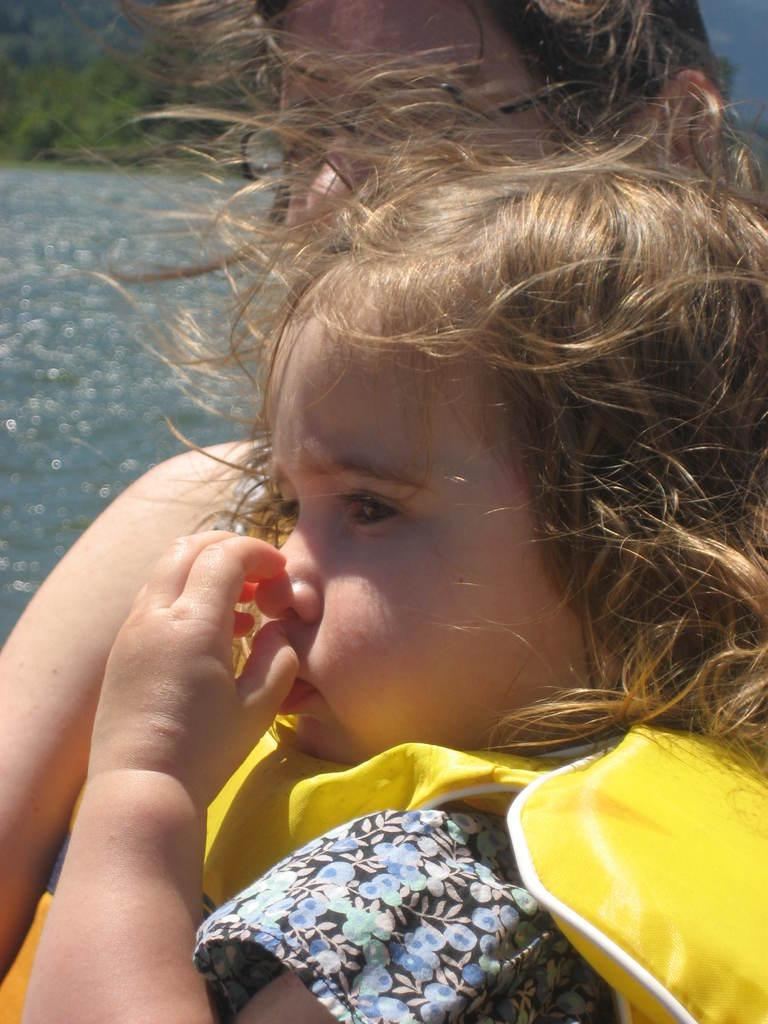Who is present in the image? A: There is a lady and a girl in the image. What is the girl wearing? The girl is wearing a life jacket. What can be seen in the background of the image? There are trees visible in the image. What is the condition of the background in the image? The background of the image is blurred. What year is depicted in the image? The provided facts do not mention any specific year, so it cannot be determined from the image. How many eyes does the lady have in the image? The provided facts do not mention the number of eyes the lady has, so it cannot be determined from the image. 